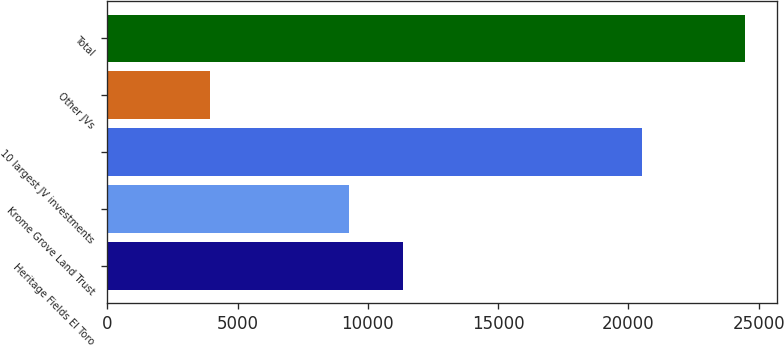Convert chart to OTSL. <chart><loc_0><loc_0><loc_500><loc_500><bar_chart><fcel>Heritage Fields El Toro<fcel>Krome Grove Land Trust<fcel>10 largest JV investments<fcel>Other JVs<fcel>Total<nl><fcel>11329.2<fcel>9276<fcel>20532<fcel>3949<fcel>24481<nl></chart> 